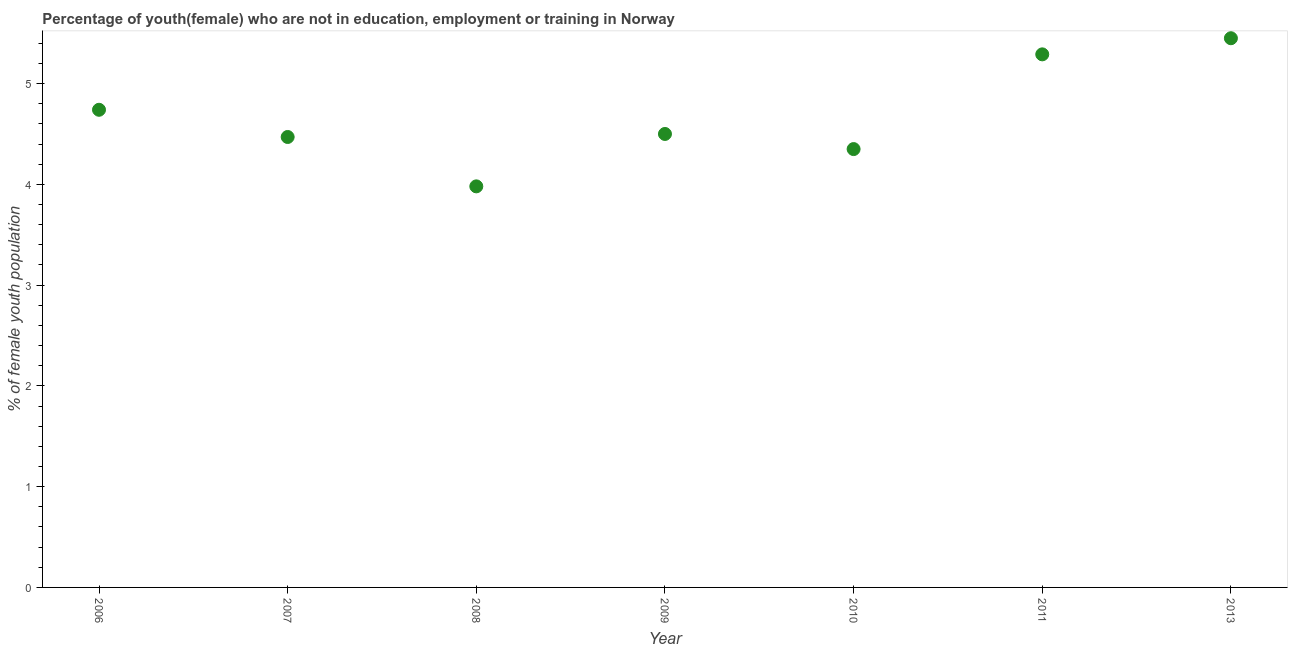What is the unemployed female youth population in 2010?
Provide a short and direct response. 4.35. Across all years, what is the maximum unemployed female youth population?
Your answer should be compact. 5.45. Across all years, what is the minimum unemployed female youth population?
Offer a very short reply. 3.98. In which year was the unemployed female youth population maximum?
Your response must be concise. 2013. What is the sum of the unemployed female youth population?
Your answer should be very brief. 32.78. What is the difference between the unemployed female youth population in 2006 and 2011?
Provide a succinct answer. -0.55. What is the average unemployed female youth population per year?
Offer a terse response. 4.68. What is the median unemployed female youth population?
Your answer should be very brief. 4.5. In how many years, is the unemployed female youth population greater than 2.8 %?
Your response must be concise. 7. Do a majority of the years between 2007 and 2011 (inclusive) have unemployed female youth population greater than 1.8 %?
Provide a short and direct response. Yes. What is the ratio of the unemployed female youth population in 2006 to that in 2010?
Your answer should be very brief. 1.09. Is the unemployed female youth population in 2006 less than that in 2009?
Give a very brief answer. No. Is the difference between the unemployed female youth population in 2010 and 2013 greater than the difference between any two years?
Your answer should be compact. No. What is the difference between the highest and the second highest unemployed female youth population?
Your answer should be very brief. 0.16. What is the difference between the highest and the lowest unemployed female youth population?
Ensure brevity in your answer.  1.47. Does the unemployed female youth population monotonically increase over the years?
Provide a succinct answer. No. How many years are there in the graph?
Keep it short and to the point. 7. Does the graph contain grids?
Offer a terse response. No. What is the title of the graph?
Give a very brief answer. Percentage of youth(female) who are not in education, employment or training in Norway. What is the label or title of the X-axis?
Your answer should be very brief. Year. What is the label or title of the Y-axis?
Your answer should be compact. % of female youth population. What is the % of female youth population in 2006?
Your answer should be compact. 4.74. What is the % of female youth population in 2007?
Ensure brevity in your answer.  4.47. What is the % of female youth population in 2008?
Offer a very short reply. 3.98. What is the % of female youth population in 2009?
Offer a very short reply. 4.5. What is the % of female youth population in 2010?
Provide a succinct answer. 4.35. What is the % of female youth population in 2011?
Ensure brevity in your answer.  5.29. What is the % of female youth population in 2013?
Your response must be concise. 5.45. What is the difference between the % of female youth population in 2006 and 2007?
Your answer should be very brief. 0.27. What is the difference between the % of female youth population in 2006 and 2008?
Provide a short and direct response. 0.76. What is the difference between the % of female youth population in 2006 and 2009?
Offer a terse response. 0.24. What is the difference between the % of female youth population in 2006 and 2010?
Provide a succinct answer. 0.39. What is the difference between the % of female youth population in 2006 and 2011?
Your response must be concise. -0.55. What is the difference between the % of female youth population in 2006 and 2013?
Give a very brief answer. -0.71. What is the difference between the % of female youth population in 2007 and 2008?
Ensure brevity in your answer.  0.49. What is the difference between the % of female youth population in 2007 and 2009?
Offer a terse response. -0.03. What is the difference between the % of female youth population in 2007 and 2010?
Keep it short and to the point. 0.12. What is the difference between the % of female youth population in 2007 and 2011?
Provide a succinct answer. -0.82. What is the difference between the % of female youth population in 2007 and 2013?
Provide a succinct answer. -0.98. What is the difference between the % of female youth population in 2008 and 2009?
Give a very brief answer. -0.52. What is the difference between the % of female youth population in 2008 and 2010?
Provide a succinct answer. -0.37. What is the difference between the % of female youth population in 2008 and 2011?
Keep it short and to the point. -1.31. What is the difference between the % of female youth population in 2008 and 2013?
Your answer should be compact. -1.47. What is the difference between the % of female youth population in 2009 and 2010?
Provide a short and direct response. 0.15. What is the difference between the % of female youth population in 2009 and 2011?
Your answer should be very brief. -0.79. What is the difference between the % of female youth population in 2009 and 2013?
Ensure brevity in your answer.  -0.95. What is the difference between the % of female youth population in 2010 and 2011?
Keep it short and to the point. -0.94. What is the difference between the % of female youth population in 2010 and 2013?
Give a very brief answer. -1.1. What is the difference between the % of female youth population in 2011 and 2013?
Ensure brevity in your answer.  -0.16. What is the ratio of the % of female youth population in 2006 to that in 2007?
Give a very brief answer. 1.06. What is the ratio of the % of female youth population in 2006 to that in 2008?
Your answer should be very brief. 1.19. What is the ratio of the % of female youth population in 2006 to that in 2009?
Ensure brevity in your answer.  1.05. What is the ratio of the % of female youth population in 2006 to that in 2010?
Offer a very short reply. 1.09. What is the ratio of the % of female youth population in 2006 to that in 2011?
Make the answer very short. 0.9. What is the ratio of the % of female youth population in 2006 to that in 2013?
Offer a terse response. 0.87. What is the ratio of the % of female youth population in 2007 to that in 2008?
Ensure brevity in your answer.  1.12. What is the ratio of the % of female youth population in 2007 to that in 2009?
Provide a short and direct response. 0.99. What is the ratio of the % of female youth population in 2007 to that in 2010?
Make the answer very short. 1.03. What is the ratio of the % of female youth population in 2007 to that in 2011?
Your answer should be very brief. 0.84. What is the ratio of the % of female youth population in 2007 to that in 2013?
Your answer should be compact. 0.82. What is the ratio of the % of female youth population in 2008 to that in 2009?
Keep it short and to the point. 0.88. What is the ratio of the % of female youth population in 2008 to that in 2010?
Ensure brevity in your answer.  0.92. What is the ratio of the % of female youth population in 2008 to that in 2011?
Make the answer very short. 0.75. What is the ratio of the % of female youth population in 2008 to that in 2013?
Keep it short and to the point. 0.73. What is the ratio of the % of female youth population in 2009 to that in 2010?
Your answer should be compact. 1.03. What is the ratio of the % of female youth population in 2009 to that in 2011?
Provide a short and direct response. 0.85. What is the ratio of the % of female youth population in 2009 to that in 2013?
Your answer should be very brief. 0.83. What is the ratio of the % of female youth population in 2010 to that in 2011?
Offer a very short reply. 0.82. What is the ratio of the % of female youth population in 2010 to that in 2013?
Your response must be concise. 0.8. 